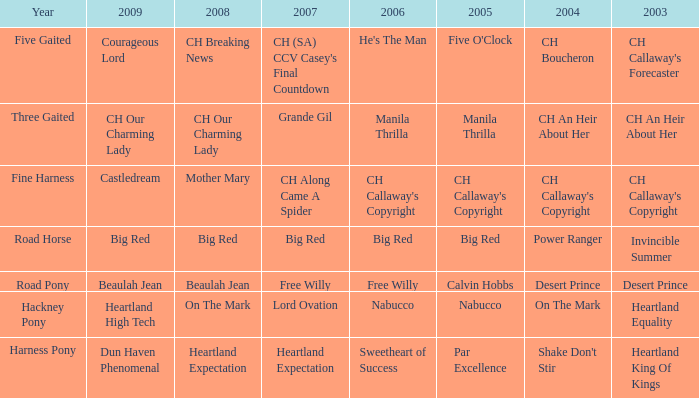What is the 2007 with ch callaway's copyright in 2003? CH Along Came A Spider. 